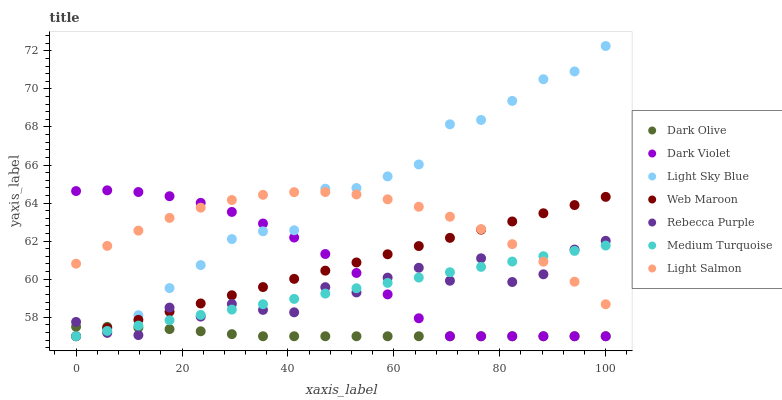Does Dark Olive have the minimum area under the curve?
Answer yes or no. Yes. Does Light Sky Blue have the maximum area under the curve?
Answer yes or no. Yes. Does Web Maroon have the minimum area under the curve?
Answer yes or no. No. Does Web Maroon have the maximum area under the curve?
Answer yes or no. No. Is Medium Turquoise the smoothest?
Answer yes or no. Yes. Is Rebecca Purple the roughest?
Answer yes or no. Yes. Is Dark Olive the smoothest?
Answer yes or no. No. Is Dark Olive the roughest?
Answer yes or no. No. Does Dark Olive have the lowest value?
Answer yes or no. Yes. Does Rebecca Purple have the lowest value?
Answer yes or no. No. Does Light Sky Blue have the highest value?
Answer yes or no. Yes. Does Web Maroon have the highest value?
Answer yes or no. No. Is Dark Olive less than Light Salmon?
Answer yes or no. Yes. Is Light Salmon greater than Dark Olive?
Answer yes or no. Yes. Does Dark Violet intersect Rebecca Purple?
Answer yes or no. Yes. Is Dark Violet less than Rebecca Purple?
Answer yes or no. No. Is Dark Violet greater than Rebecca Purple?
Answer yes or no. No. Does Dark Olive intersect Light Salmon?
Answer yes or no. No. 